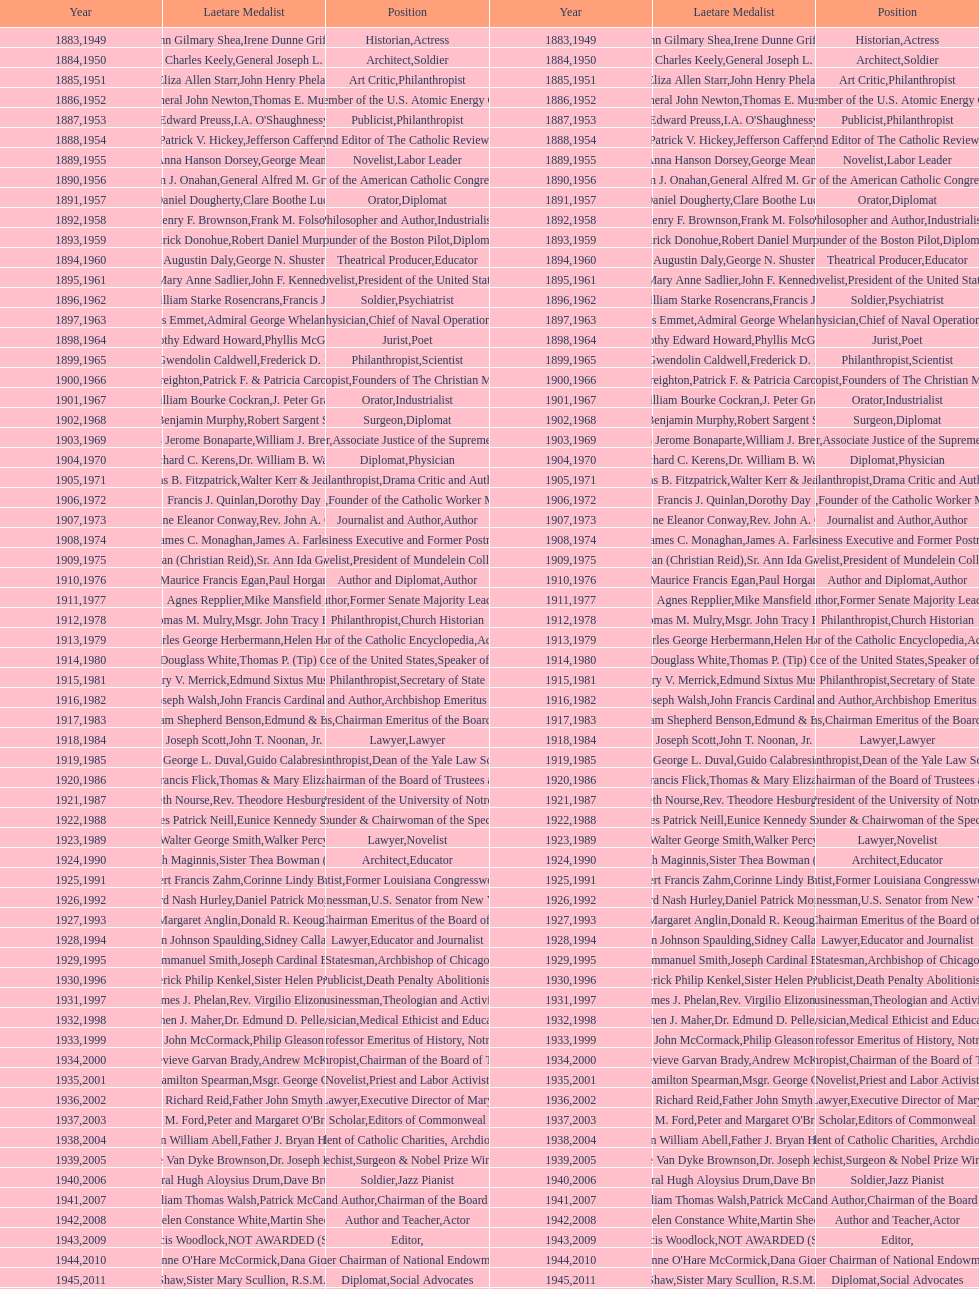What are the number of laetare medalist that held a diplomat position? 8. 